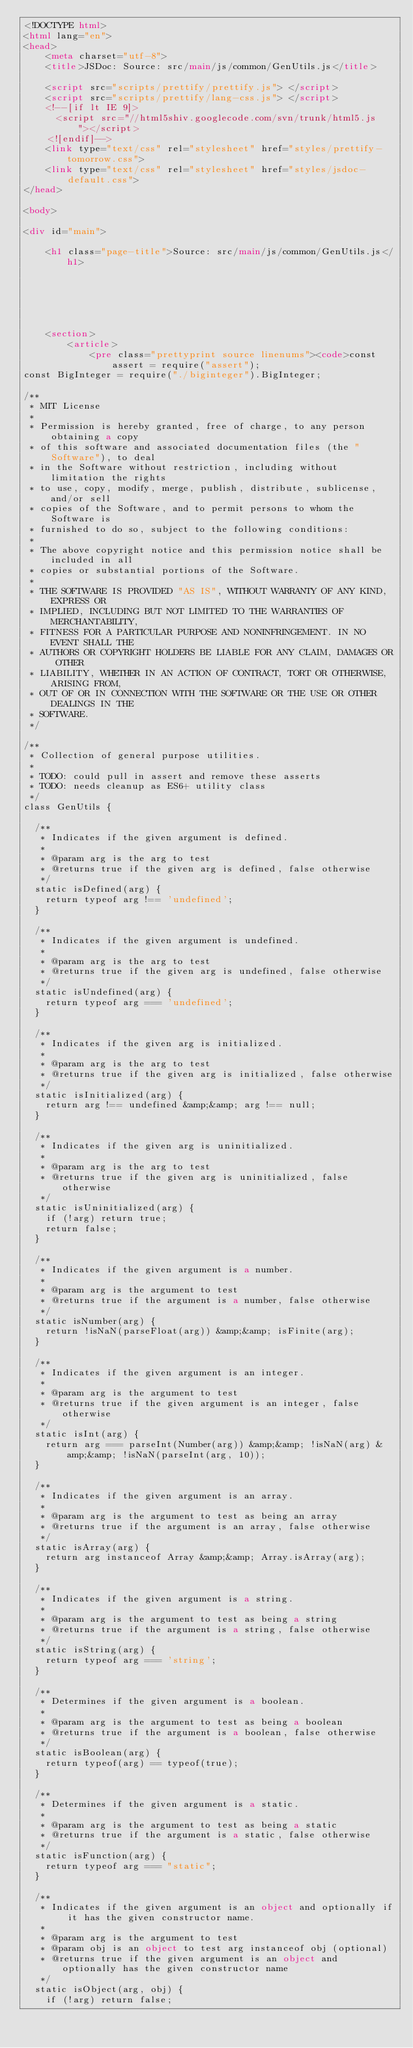<code> <loc_0><loc_0><loc_500><loc_500><_HTML_><!DOCTYPE html>
<html lang="en">
<head>
    <meta charset="utf-8">
    <title>JSDoc: Source: src/main/js/common/GenUtils.js</title>

    <script src="scripts/prettify/prettify.js"> </script>
    <script src="scripts/prettify/lang-css.js"> </script>
    <!--[if lt IE 9]>
      <script src="//html5shiv.googlecode.com/svn/trunk/html5.js"></script>
    <![endif]-->
    <link type="text/css" rel="stylesheet" href="styles/prettify-tomorrow.css">
    <link type="text/css" rel="stylesheet" href="styles/jsdoc-default.css">
</head>

<body>

<div id="main">

    <h1 class="page-title">Source: src/main/js/common/GenUtils.js</h1>

    



    
    <section>
        <article>
            <pre class="prettyprint source linenums"><code>const assert = require("assert");
const BigInteger = require("./biginteger").BigInteger;

/**
 * MIT License
 * 
 * Permission is hereby granted, free of charge, to any person obtaining a copy
 * of this software and associated documentation files (the "Software"), to deal
 * in the Software without restriction, including without limitation the rights
 * to use, copy, modify, merge, publish, distribute, sublicense, and/or sell
 * copies of the Software, and to permit persons to whom the Software is
 * furnished to do so, subject to the following conditions:
 * 
 * The above copyright notice and this permission notice shall be included in all
 * copies or substantial portions of the Software.
 * 
 * THE SOFTWARE IS PROVIDED "AS IS", WITHOUT WARRANTY OF ANY KIND, EXPRESS OR
 * IMPLIED, INCLUDING BUT NOT LIMITED TO THE WARRANTIES OF MERCHANTABILITY,
 * FITNESS FOR A PARTICULAR PURPOSE AND NONINFRINGEMENT. IN NO EVENT SHALL THE
 * AUTHORS OR COPYRIGHT HOLDERS BE LIABLE FOR ANY CLAIM, DAMAGES OR OTHER
 * LIABILITY, WHETHER IN AN ACTION OF CONTRACT, TORT OR OTHERWISE, ARISING FROM,
 * OUT OF OR IN CONNECTION WITH THE SOFTWARE OR THE USE OR OTHER DEALINGS IN THE
 * SOFTWARE.
 */

/**
 * Collection of general purpose utilities.
 * 
 * TODO: could pull in assert and remove these asserts
 * TODO: needs cleanup as ES6+ utility class
 */
class GenUtils {
  
  /**
   * Indicates if the given argument is defined.
   * 
   * @param arg is the arg to test
   * @returns true if the given arg is defined, false otherwise
   */
  static isDefined(arg) {
    return typeof arg !== 'undefined';
  }

  /**
   * Indicates if the given argument is undefined.
   * 
   * @param arg is the arg to test
   * @returns true if the given arg is undefined, false otherwise
   */
  static isUndefined(arg) {
    return typeof arg === 'undefined';
  }

  /**
   * Indicates if the given arg is initialized.
   * 
   * @param arg is the arg to test
   * @returns true if the given arg is initialized, false otherwise
   */
  static isInitialized(arg) {
    return arg !== undefined &amp;&amp; arg !== null;
  }

  /**
   * Indicates if the given arg is uninitialized.
   * 
   * @param arg is the arg to test
   * @returns true if the given arg is uninitialized, false otherwise
   */
  static isUninitialized(arg) {
    if (!arg) return true;
    return false;
  }

  /**
   * Indicates if the given argument is a number.
   * 
   * @param arg is the argument to test
   * @returns true if the argument is a number, false otherwise
   */
  static isNumber(arg) {
    return !isNaN(parseFloat(arg)) &amp;&amp; isFinite(arg);
  }

  /**
   * Indicates if the given argument is an integer.
   * 
   * @param arg is the argument to test
   * @returns true if the given argument is an integer, false otherwise
   */
  static isInt(arg) {
    return arg === parseInt(Number(arg)) &amp;&amp; !isNaN(arg) &amp;&amp; !isNaN(parseInt(arg, 10));
  }

  /**
   * Indicates if the given argument is an array.
   * 
   * @param arg is the argument to test as being an array
   * @returns true if the argument is an array, false otherwise
   */
  static isArray(arg) {
    return arg instanceof Array &amp;&amp; Array.isArray(arg);
  }

  /**
   * Indicates if the given argument is a string.
   * 
   * @param arg is the argument to test as being a string
   * @returns true if the argument is a string, false otherwise
   */
  static isString(arg) {
    return typeof arg === 'string';
  }

  /**
   * Determines if the given argument is a boolean.
   * 
   * @param arg is the argument to test as being a boolean
   * @returns true if the argument is a boolean, false otherwise
   */
  static isBoolean(arg) {
    return typeof(arg) == typeof(true);
  }

  /**
   * Determines if the given argument is a static.
   * 
   * @param arg is the argument to test as being a static
   * @returns true if the argument is a static, false otherwise
   */
  static isFunction(arg) {
    return typeof arg === "static";
  }

  /**
   * Indicates if the given argument is an object and optionally if it has the given constructor name.
   * 
   * @param arg is the argument to test
   * @param obj is an object to test arg instanceof obj (optional)
   * @returns true if the given argument is an object and optionally has the given constructor name
   */
  static isObject(arg, obj) {
    if (!arg) return false;</code> 